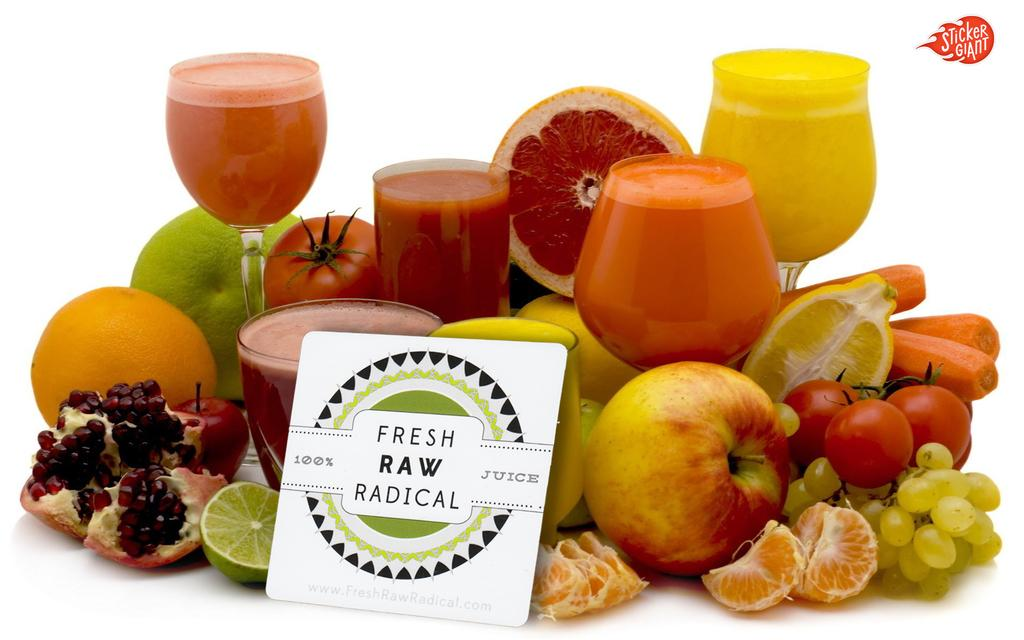What type of food items can be seen in the image? There are fruits in the image. What objects are also visible in the image? There are glasses and a board in the image. What color is the background of the image? The background of the image is white. What type of music is the band playing in the background of the image? There is no band present in the image, so it is not possible to determine what type of music might be playing. 